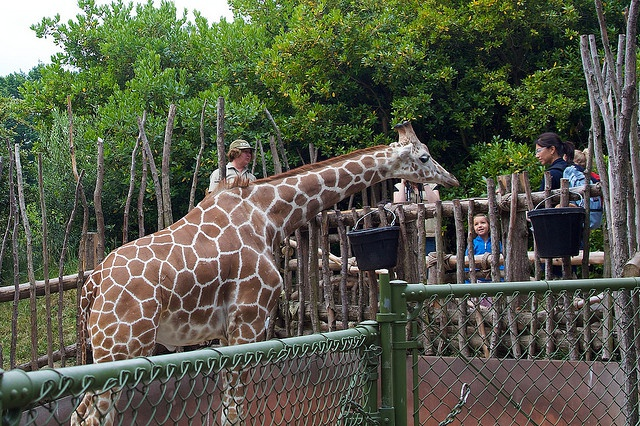Describe the objects in this image and their specific colors. I can see giraffe in white, gray, darkgray, and black tones, people in white, gray, black, darkgray, and maroon tones, people in white, black, navy, gray, and brown tones, people in white, lightgray, darkgray, gray, and brown tones, and backpack in white, gray, blue, navy, and black tones in this image. 